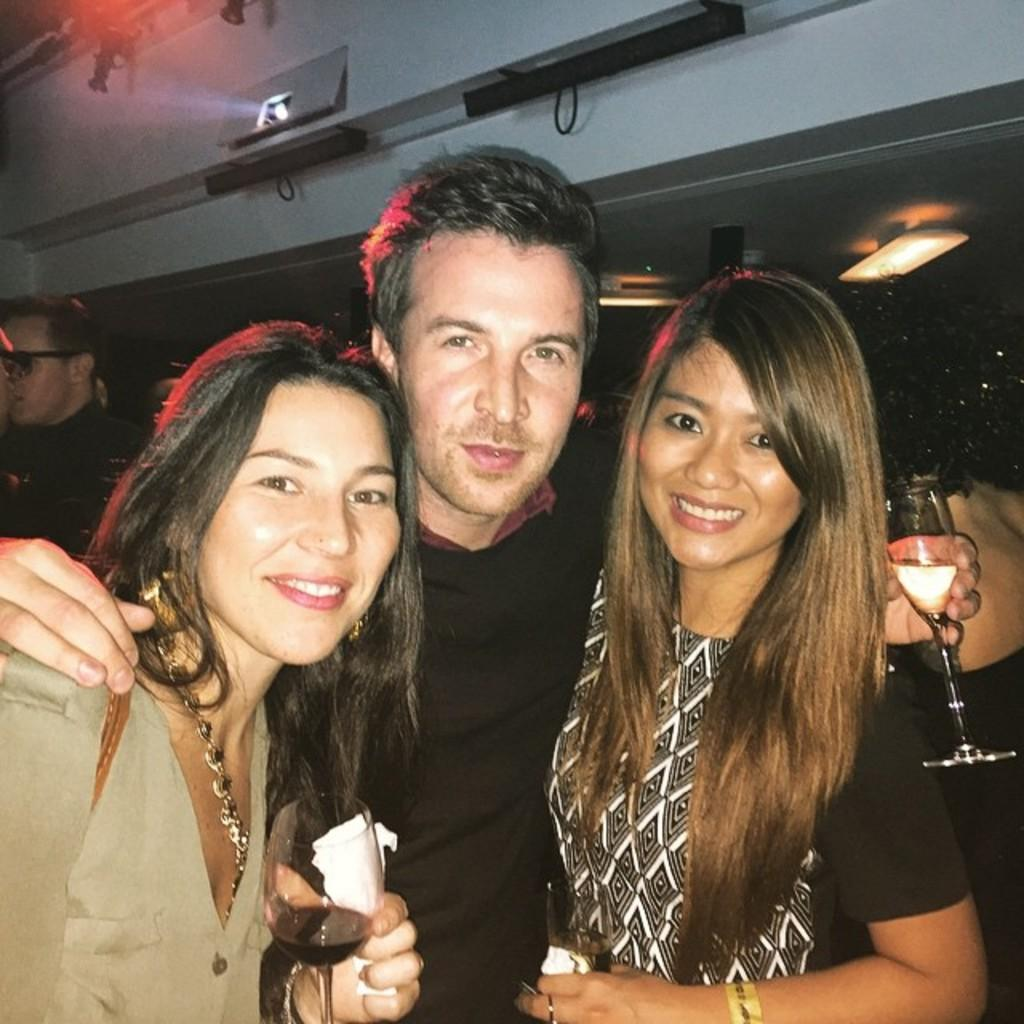How many people are in the image? There are two women and a man in the image. What are the two women and the man doing in the image? The two women and the man are standing and holding wine glasses in their hands. Can you describe the background of the image? There is a man in the background of the image, as well as a projector and lights. What type of drug is being passed around in the image? There is no drug present in the image; the two women and the man are holding wine glasses. How much sugar is visible in the image? There is no sugar visible in the image. 